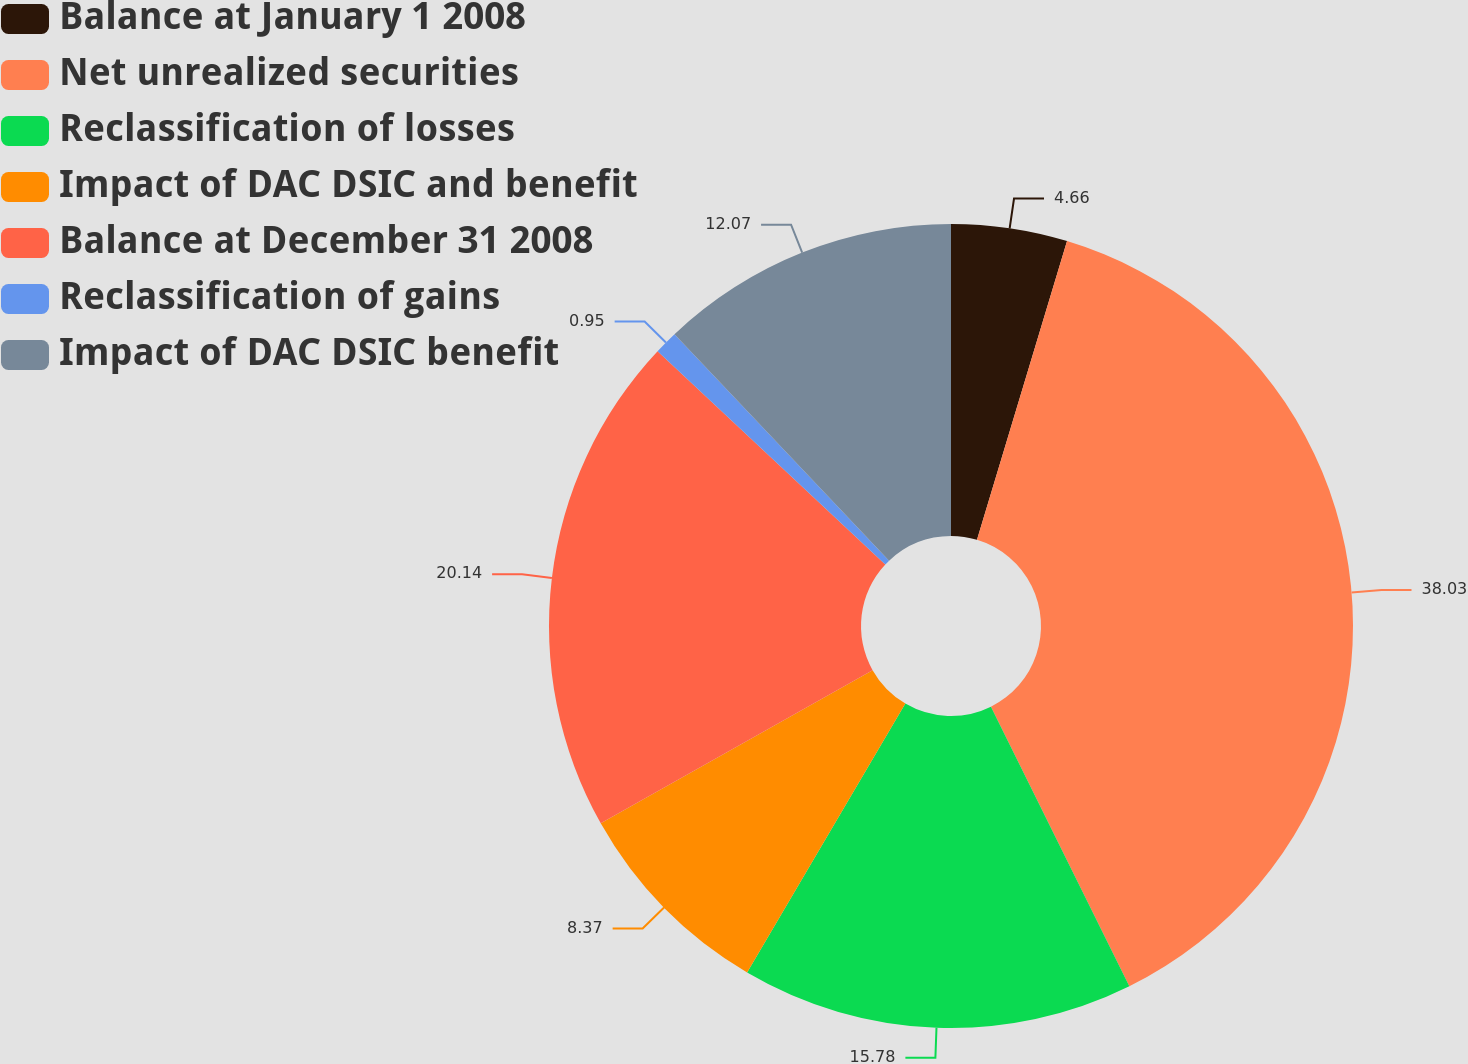Convert chart to OTSL. <chart><loc_0><loc_0><loc_500><loc_500><pie_chart><fcel>Balance at January 1 2008<fcel>Net unrealized securities<fcel>Reclassification of losses<fcel>Impact of DAC DSIC and benefit<fcel>Balance at December 31 2008<fcel>Reclassification of gains<fcel>Impact of DAC DSIC benefit<nl><fcel>4.66%<fcel>38.02%<fcel>15.78%<fcel>8.37%<fcel>20.14%<fcel>0.95%<fcel>12.07%<nl></chart> 